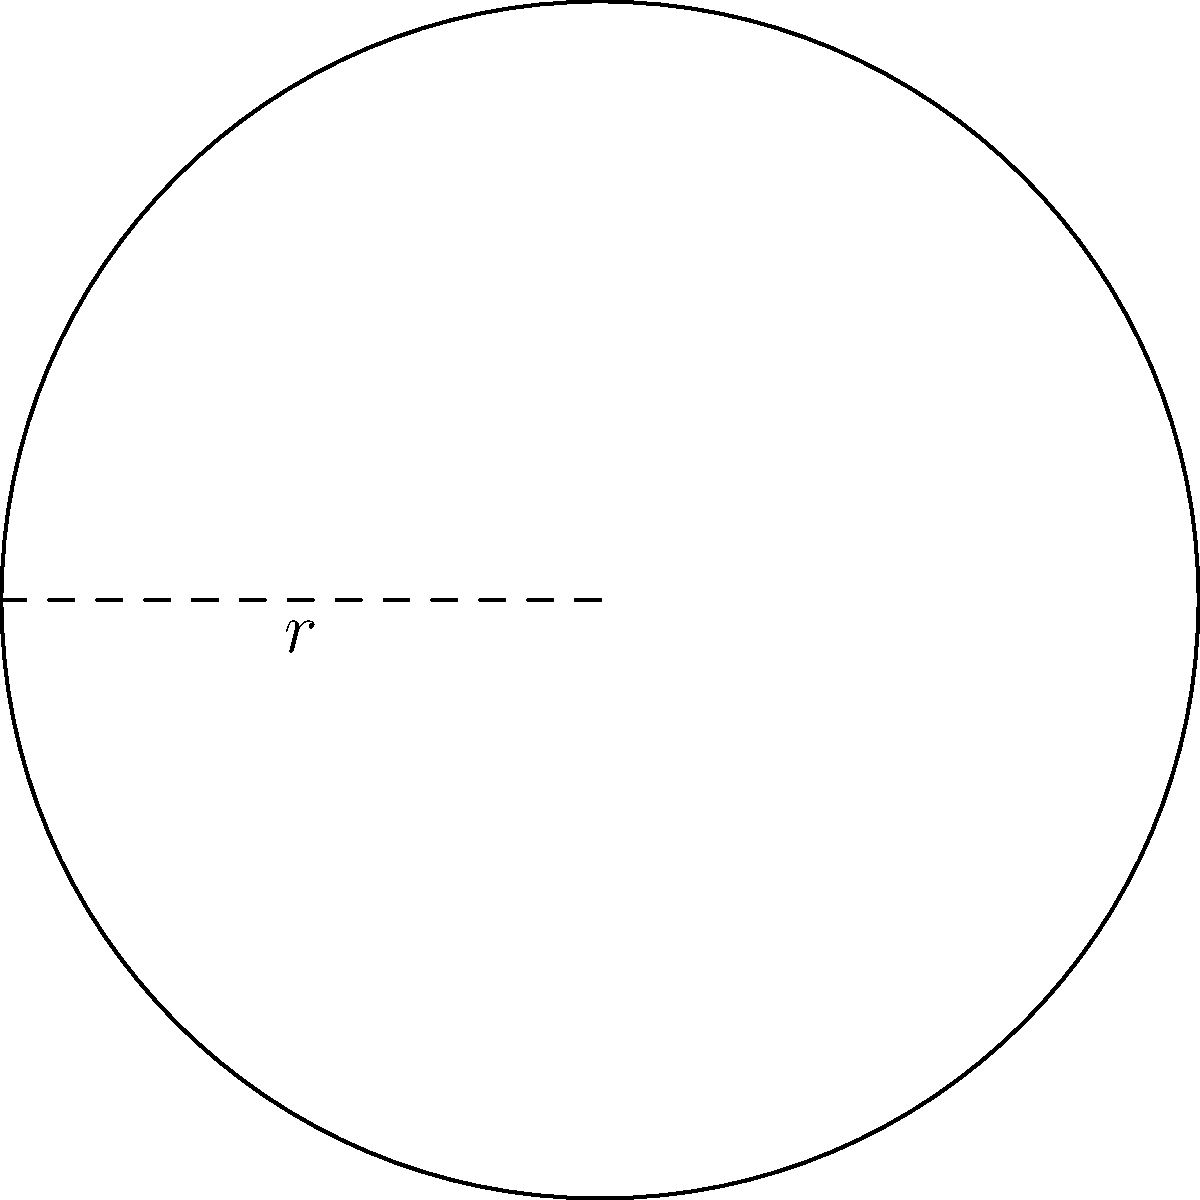Your insurance company is designing a new circular logo. The radius of the logo is 3 meters, reminiscent of the size of a professional soccer goal's radius. What is the perimeter of this circular logo? Let's approach this step-by-step:

1) The formula for the perimeter (circumference) of a circle is:
   $P = 2\pi r$, where $r$ is the radius

2) We're given that the radius is 3 meters

3) Let's substitute this into our formula:
   $P = 2\pi (3)$

4) Simplify:
   $P = 6\pi$ meters

5) If we need a numerical answer, we can use $\pi \approx 3.14159$:
   $P \approx 6 * 3.14159 \approx 18.85$ meters

Therefore, the perimeter of the circular logo is $6\pi$ meters, or approximately 18.85 meters.
Answer: $6\pi$ meters 